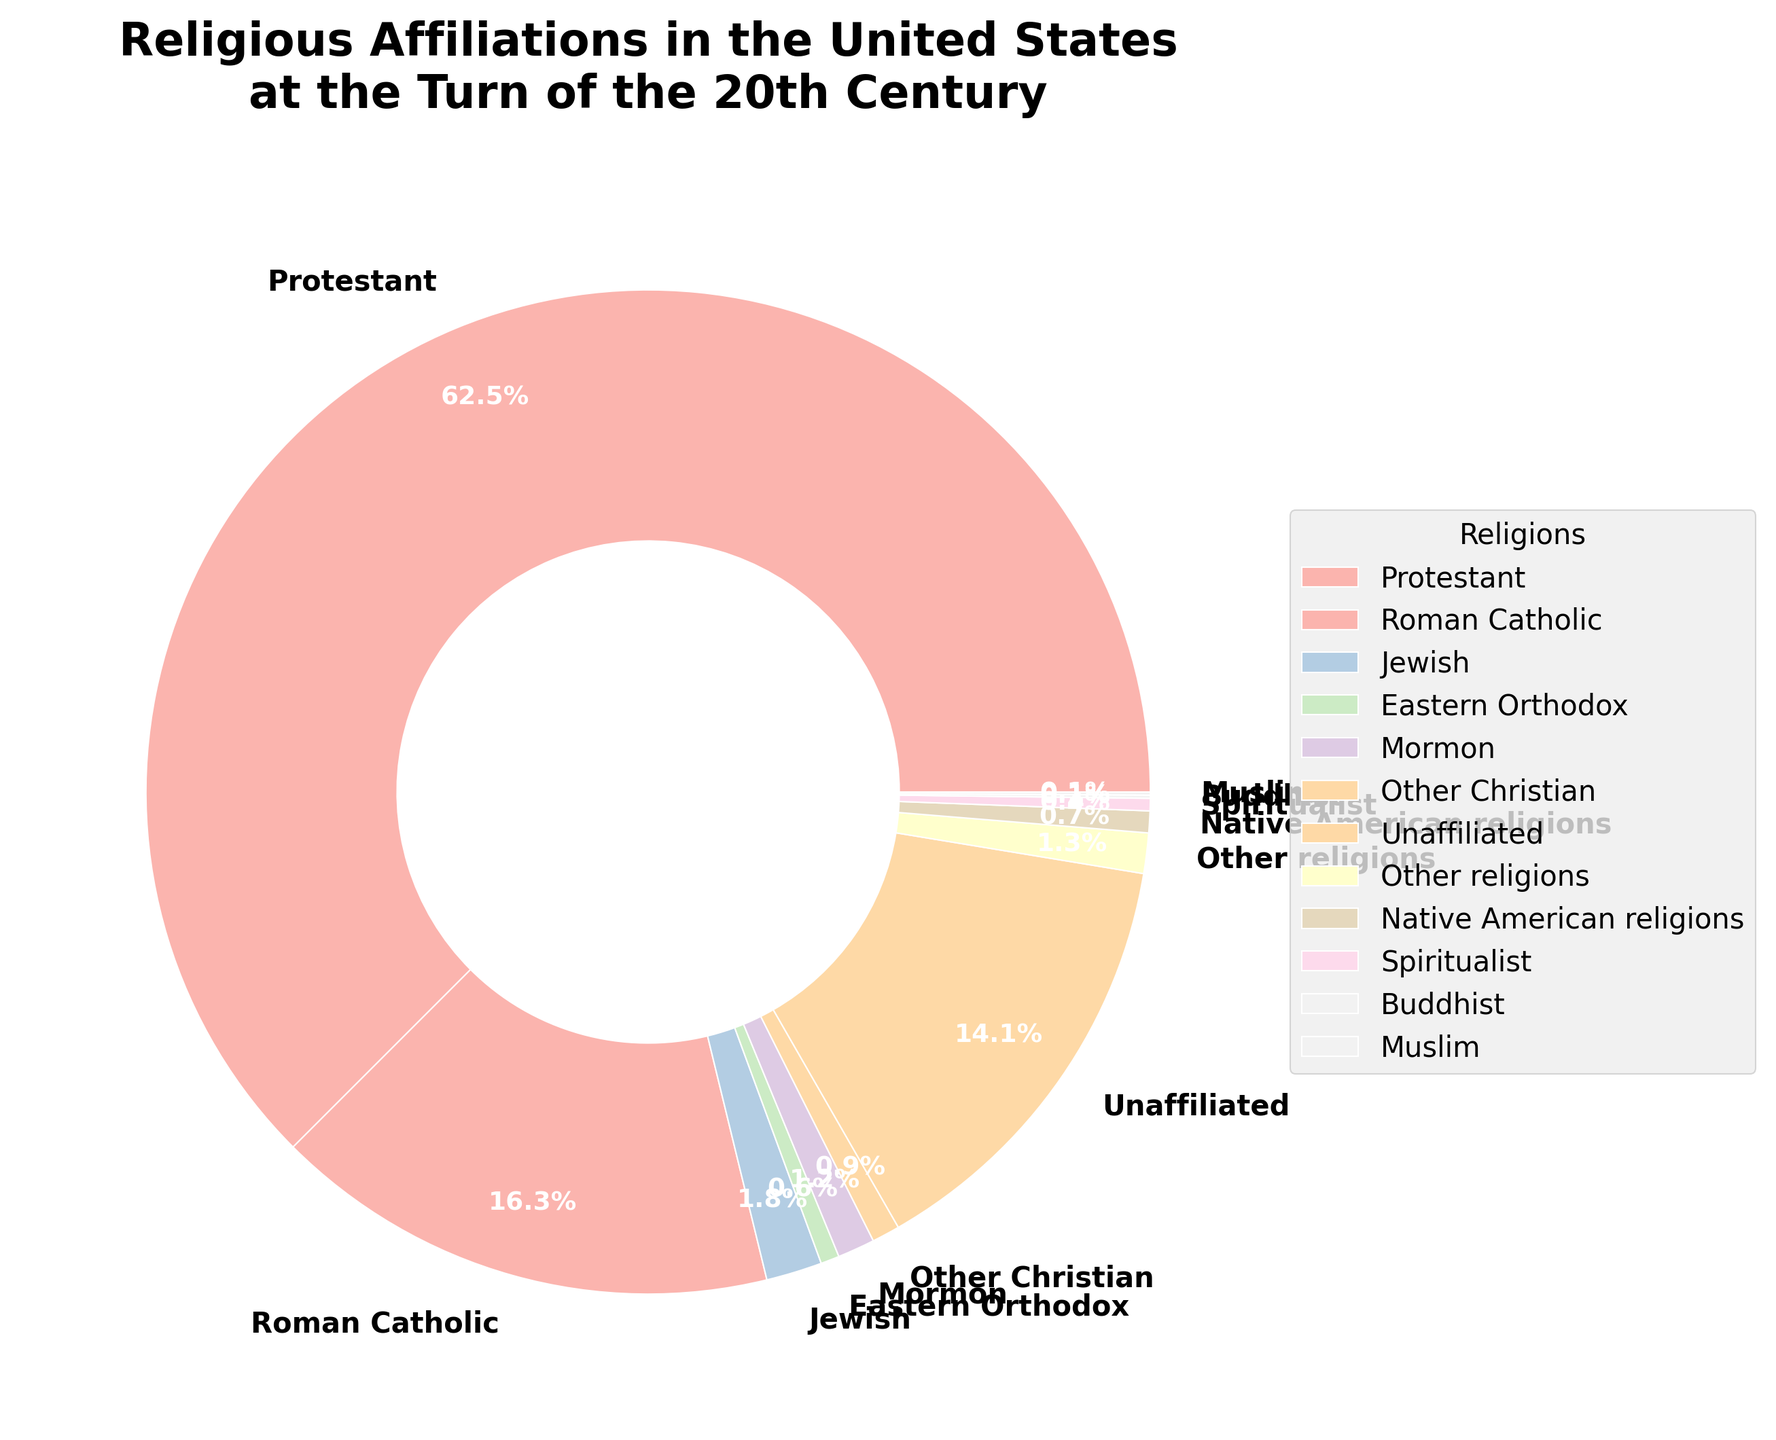What percentage of the population identified as Roman Catholic compared to Protestant? Roman Catholic is 16.3% and Protestant is 62.5%. Subtract the Roman Catholic percentage from the Protestant percentage: 62.5% - 16.3% = 46.2%.
Answer: 46.2% Summing up all the minor religions (those below 2%), what is the combined percentage? Minor religions include Jewish (1.8%), Eastern Orthodox (0.6%), Mormon (1.2%), Other Christian (0.9%), Other religions (1.3%), Native American religions (0.7%), Spiritualist (0.4%), Buddhist (0.1%), and Muslim (0.1%). Adding these: 1.8 + 0.6 + 1.2 + 0.9 + 1.3 + 0.7 + 0.4 + 0.1 + 0.1 = 7.1. Combined percentage is 7.1%.
Answer: 7.1% Are there more unaffiliated individuals or Roman Catholics in the dataset? The percentage of unaffiliated individuals is 14.1% and Roman Catholics are 16.3%. 14.1% is less than 16.3%, so there are more Roman Catholics.
Answer: Roman Catholics Which religion represents the smallest percentage and what is the value? The smallest percentages are for Buddhist and Muslim, both at 0.1%.
Answer: Buddhist and Muslim, 0.1% How much more is the percentage of Protestants compared to the sum of Mormon and Jewish percentages? Mormon is 1.2% and Jewish is 1.8%. Sum these: 1.2 + 1.8 = 3%. Protestant is 62.5%. Subtract the sum from the Protestant percentage: 62.5% - 3% = 59.5%.
Answer: 59.5% Which section of the pie chart is colored to represent Other Christian religions? The segment representing Other Christian religions is the smallest segment between 0.5% and 1.0% percentage, colored in the pastel palette. Look for the label "Other Christian."
Answer: It is a small segment in pastel color What is the combined percentage of “Other religions” and “Native American religions”? Other religions are 1.3% and Native American religions are 0.7%. Adding these together: 1.3 + 0.7 = 2.0%.
Answer: 2.0% 